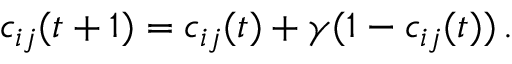Convert formula to latex. <formula><loc_0><loc_0><loc_500><loc_500>c _ { i j } ( t + 1 ) = c _ { i j } ( t ) + \gamma ( 1 - c _ { i j } ( t ) ) \, .</formula> 